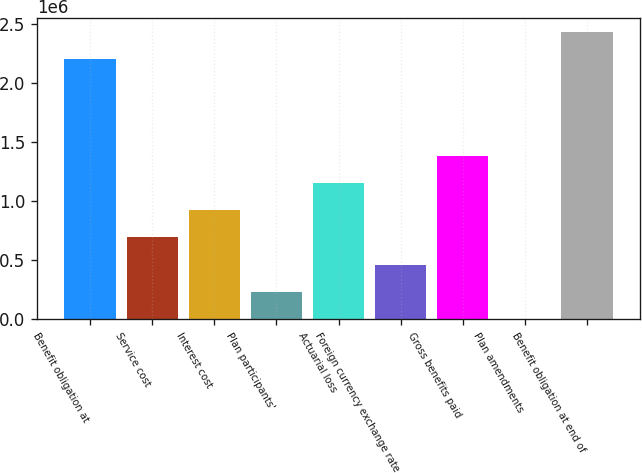<chart> <loc_0><loc_0><loc_500><loc_500><bar_chart><fcel>Benefit obligation at<fcel>Service cost<fcel>Interest cost<fcel>Plan participants'<fcel>Actuarial loss<fcel>Foreign currency exchange rate<fcel>Gross benefits paid<fcel>Plan amendments<fcel>Benefit obligation at end of<nl><fcel>2.19936e+06<fcel>693502<fcel>923981<fcel>232543<fcel>1.15446e+06<fcel>463022<fcel>1.38494e+06<fcel>2063<fcel>2.42984e+06<nl></chart> 